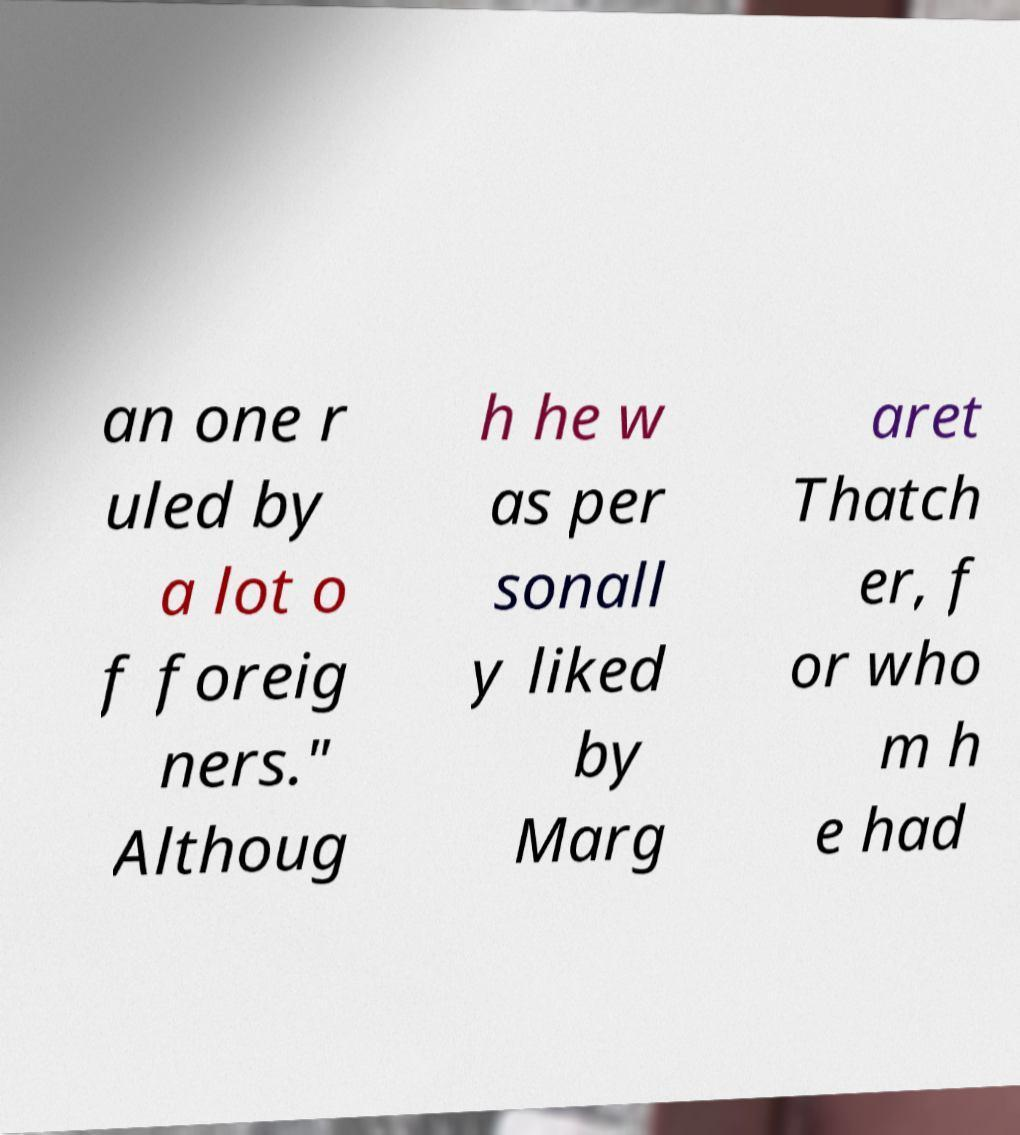I need the written content from this picture converted into text. Can you do that? an one r uled by a lot o f foreig ners." Althoug h he w as per sonall y liked by Marg aret Thatch er, f or who m h e had 